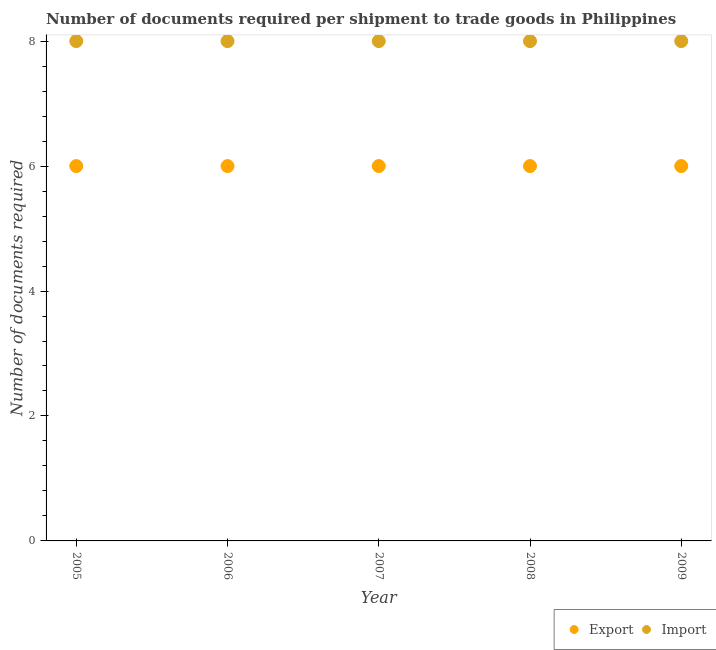How many different coloured dotlines are there?
Offer a very short reply. 2. Is the number of dotlines equal to the number of legend labels?
Ensure brevity in your answer.  Yes. What is the number of documents required to import goods in 2008?
Your answer should be compact. 8. Across all years, what is the maximum number of documents required to import goods?
Give a very brief answer. 8. In which year was the number of documents required to export goods maximum?
Offer a very short reply. 2005. What is the total number of documents required to import goods in the graph?
Keep it short and to the point. 40. What is the difference between the number of documents required to import goods in 2005 and that in 2008?
Give a very brief answer. 0. What is the difference between the number of documents required to export goods in 2009 and the number of documents required to import goods in 2008?
Offer a very short reply. -2. What is the average number of documents required to export goods per year?
Offer a very short reply. 6. In the year 2005, what is the difference between the number of documents required to import goods and number of documents required to export goods?
Make the answer very short. 2. Is the number of documents required to export goods in 2007 less than that in 2008?
Provide a short and direct response. No. Is the difference between the number of documents required to export goods in 2008 and 2009 greater than the difference between the number of documents required to import goods in 2008 and 2009?
Ensure brevity in your answer.  No. What is the difference between the highest and the second highest number of documents required to export goods?
Offer a very short reply. 0. What is the difference between the highest and the lowest number of documents required to export goods?
Your answer should be very brief. 0. In how many years, is the number of documents required to import goods greater than the average number of documents required to import goods taken over all years?
Keep it short and to the point. 0. Is the sum of the number of documents required to export goods in 2008 and 2009 greater than the maximum number of documents required to import goods across all years?
Provide a succinct answer. Yes. Does the number of documents required to import goods monotonically increase over the years?
Make the answer very short. No. Is the number of documents required to export goods strictly greater than the number of documents required to import goods over the years?
Give a very brief answer. No. Does the graph contain any zero values?
Ensure brevity in your answer.  No. How many legend labels are there?
Your response must be concise. 2. How are the legend labels stacked?
Your answer should be very brief. Horizontal. What is the title of the graph?
Your answer should be very brief. Number of documents required per shipment to trade goods in Philippines. What is the label or title of the Y-axis?
Keep it short and to the point. Number of documents required. What is the Number of documents required of Import in 2005?
Provide a succinct answer. 8. What is the Number of documents required in Import in 2006?
Provide a short and direct response. 8. What is the Number of documents required in Export in 2007?
Offer a very short reply. 6. What is the Number of documents required in Import in 2007?
Your answer should be very brief. 8. What is the Number of documents required in Export in 2008?
Make the answer very short. 6. What is the Number of documents required in Import in 2008?
Give a very brief answer. 8. What is the Number of documents required of Export in 2009?
Offer a very short reply. 6. Across all years, what is the maximum Number of documents required in Import?
Provide a short and direct response. 8. Across all years, what is the minimum Number of documents required of Import?
Make the answer very short. 8. What is the total Number of documents required of Export in the graph?
Provide a short and direct response. 30. What is the difference between the Number of documents required of Import in 2005 and that in 2006?
Ensure brevity in your answer.  0. What is the difference between the Number of documents required of Export in 2005 and that in 2008?
Your response must be concise. 0. What is the difference between the Number of documents required of Import in 2005 and that in 2008?
Your response must be concise. 0. What is the difference between the Number of documents required in Export in 2005 and that in 2009?
Your response must be concise. 0. What is the difference between the Number of documents required of Export in 2006 and that in 2008?
Ensure brevity in your answer.  0. What is the difference between the Number of documents required in Import in 2006 and that in 2008?
Keep it short and to the point. 0. What is the difference between the Number of documents required in Export in 2007 and that in 2008?
Provide a short and direct response. 0. What is the difference between the Number of documents required in Export in 2007 and that in 2009?
Your answer should be very brief. 0. What is the difference between the Number of documents required in Import in 2007 and that in 2009?
Your answer should be compact. 0. What is the difference between the Number of documents required of Export in 2008 and that in 2009?
Provide a short and direct response. 0. What is the difference between the Number of documents required of Export in 2005 and the Number of documents required of Import in 2006?
Provide a succinct answer. -2. What is the difference between the Number of documents required in Export in 2005 and the Number of documents required in Import in 2007?
Offer a very short reply. -2. What is the difference between the Number of documents required of Export in 2006 and the Number of documents required of Import in 2007?
Ensure brevity in your answer.  -2. What is the difference between the Number of documents required of Export in 2006 and the Number of documents required of Import in 2009?
Your response must be concise. -2. What is the difference between the Number of documents required of Export in 2007 and the Number of documents required of Import in 2008?
Keep it short and to the point. -2. In the year 2005, what is the difference between the Number of documents required of Export and Number of documents required of Import?
Provide a succinct answer. -2. In the year 2008, what is the difference between the Number of documents required of Export and Number of documents required of Import?
Your answer should be compact. -2. What is the ratio of the Number of documents required in Export in 2005 to that in 2006?
Your answer should be very brief. 1. What is the ratio of the Number of documents required of Export in 2005 to that in 2007?
Ensure brevity in your answer.  1. What is the ratio of the Number of documents required of Import in 2005 to that in 2007?
Give a very brief answer. 1. What is the ratio of the Number of documents required of Import in 2005 to that in 2008?
Provide a short and direct response. 1. What is the ratio of the Number of documents required of Export in 2005 to that in 2009?
Your response must be concise. 1. What is the ratio of the Number of documents required in Import in 2005 to that in 2009?
Keep it short and to the point. 1. What is the ratio of the Number of documents required in Export in 2006 to that in 2007?
Offer a terse response. 1. What is the ratio of the Number of documents required in Export in 2006 to that in 2008?
Offer a terse response. 1. What is the ratio of the Number of documents required of Export in 2006 to that in 2009?
Keep it short and to the point. 1. What is the ratio of the Number of documents required of Import in 2006 to that in 2009?
Give a very brief answer. 1. What is the ratio of the Number of documents required of Import in 2007 to that in 2008?
Keep it short and to the point. 1. What is the difference between the highest and the second highest Number of documents required in Export?
Provide a succinct answer. 0. What is the difference between the highest and the lowest Number of documents required in Export?
Make the answer very short. 0. What is the difference between the highest and the lowest Number of documents required in Import?
Your response must be concise. 0. 